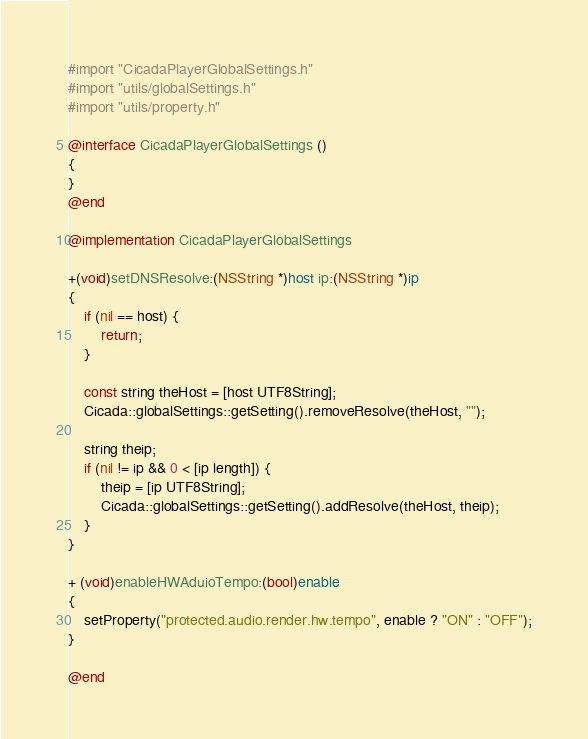Convert code to text. <code><loc_0><loc_0><loc_500><loc_500><_ObjectiveC_>#import "CicadaPlayerGlobalSettings.h"
#import "utils/globalSettings.h"
#import "utils/property.h"

@interface CicadaPlayerGlobalSettings ()
{
}
@end

@implementation CicadaPlayerGlobalSettings

+(void)setDNSResolve:(NSString *)host ip:(NSString *)ip
{
    if (nil == host) {
        return;
    }

    const string theHost = [host UTF8String];
    Cicada::globalSettings::getSetting().removeResolve(theHost, "");

    string theip;
    if (nil != ip && 0 < [ip length]) {
        theip = [ip UTF8String];
        Cicada::globalSettings::getSetting().addResolve(theHost, theip);
    }
}

+ (void)enableHWAduioTempo:(bool)enable
{
    setProperty("protected.audio.render.hw.tempo", enable ? "ON" : "OFF");
}

@end
</code> 